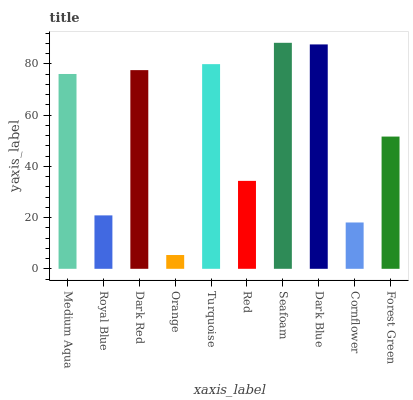Is Royal Blue the minimum?
Answer yes or no. No. Is Royal Blue the maximum?
Answer yes or no. No. Is Medium Aqua greater than Royal Blue?
Answer yes or no. Yes. Is Royal Blue less than Medium Aqua?
Answer yes or no. Yes. Is Royal Blue greater than Medium Aqua?
Answer yes or no. No. Is Medium Aqua less than Royal Blue?
Answer yes or no. No. Is Medium Aqua the high median?
Answer yes or no. Yes. Is Forest Green the low median?
Answer yes or no. Yes. Is Dark Red the high median?
Answer yes or no. No. Is Red the low median?
Answer yes or no. No. 